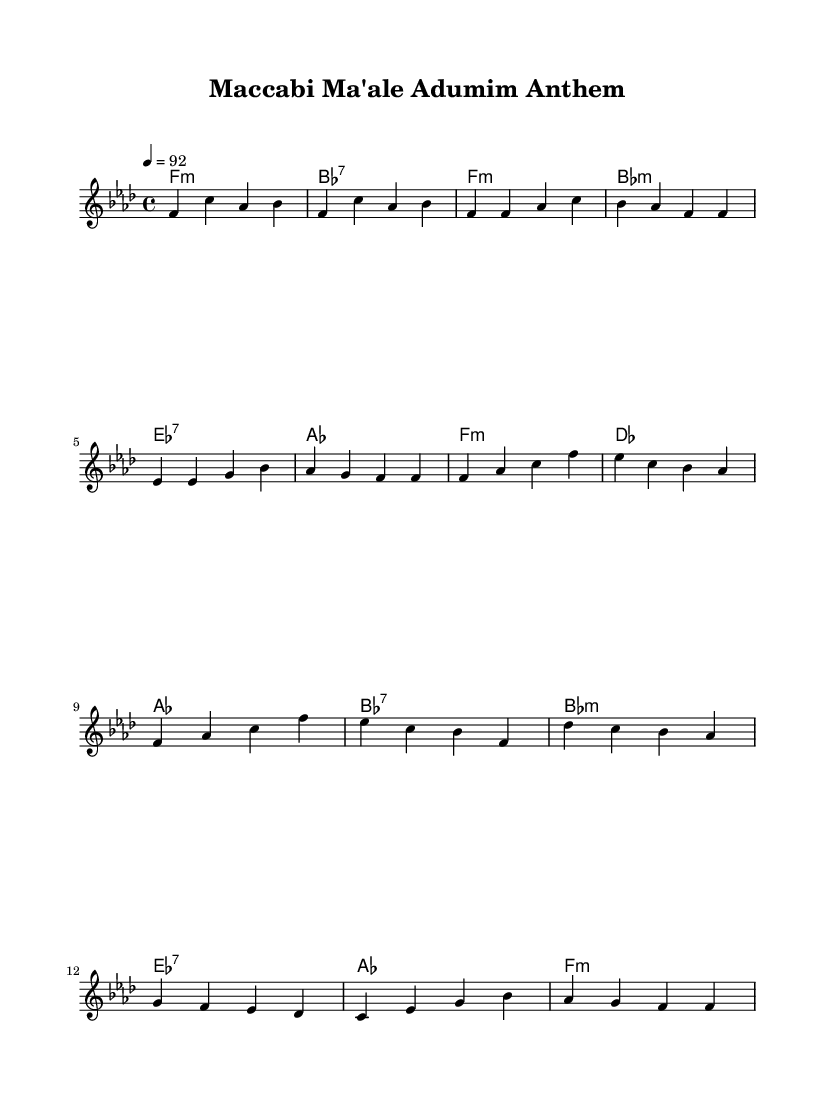What is the key signature of this music? The key signature is F minor, indicated by 4 flats (B♭, E♭, A♭, and D♭) in the staff.
Answer: F minor What is the time signature of this music? The time signature is 4/4, as indicated at the beginning of the score, which shows that there are four beats per measure.
Answer: 4/4 What is the tempo of this music? The tempo is 92 beats per minute, as specified in the tempo marking at the beginning of the score.
Answer: 92 What type of chords are used in the Chorus section? In the Chorus, the chords used are F minor, D♭, A♭, and B♭ seventh, which can be deduced from the chord symbols above the melody notes.
Answer: F minor, D flat, A flat, B flat seventh How many measures are there in the Verse section? The Verse section consists of four measures, shown by counting the groups of notes and their corresponding rests.
Answer: 4 What is the mood conveyed by the key minor? The mood conveyed by F minor typically has a more somber or introspective feel, which applies to themes often found in rap music, reflecting emotion and storytelling.
Answer: Somber What type of musical form is predominantly used in this rap anthem? The predominant musical form here is verse-chorus, as the structure alternates between the verse and chorus sections repeatedly, a common format in rap.
Answer: Verse-chorus 